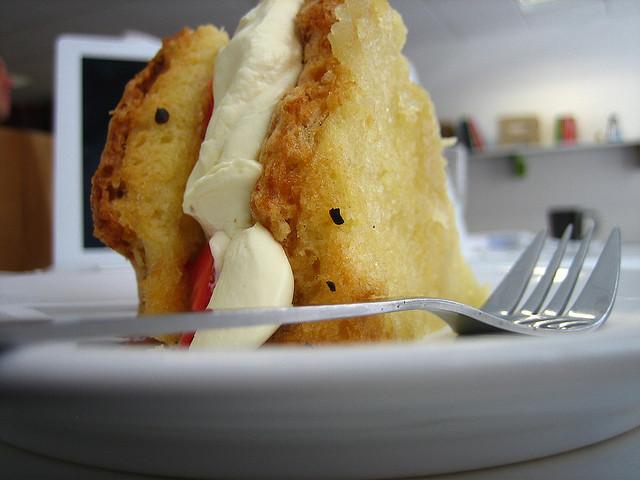Is there meat on this sandwich?
Write a very short answer. No. What do you see in the reflection on the fork?
Keep it brief. Light. What is on the plate?
Write a very short answer. Food. What silverware is on the plate?
Quick response, please. Fork. Is this a sandwich?
Quick response, please. No. Is there meat in the sandwich?
Concise answer only. No. 